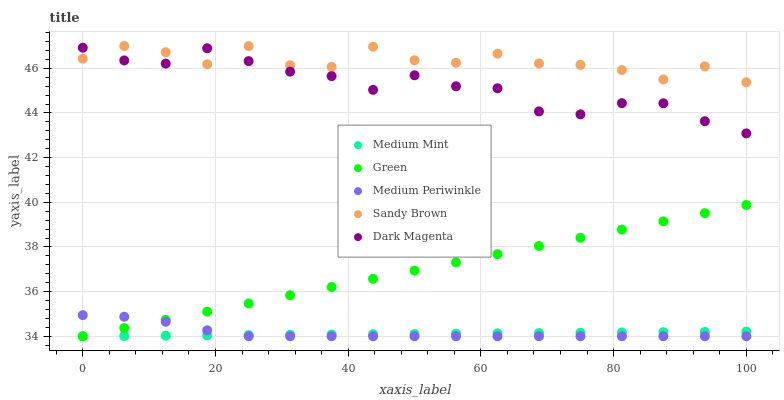Does Medium Mint have the minimum area under the curve?
Answer yes or no. Yes. Does Sandy Brown have the maximum area under the curve?
Answer yes or no. Yes. Does Medium Periwinkle have the minimum area under the curve?
Answer yes or no. No. Does Medium Periwinkle have the maximum area under the curve?
Answer yes or no. No. Is Green the smoothest?
Answer yes or no. Yes. Is Sandy Brown the roughest?
Answer yes or no. Yes. Is Medium Periwinkle the smoothest?
Answer yes or no. No. Is Medium Periwinkle the roughest?
Answer yes or no. No. Does Medium Mint have the lowest value?
Answer yes or no. Yes. Does Dark Magenta have the lowest value?
Answer yes or no. No. Does Sandy Brown have the highest value?
Answer yes or no. Yes. Does Medium Periwinkle have the highest value?
Answer yes or no. No. Is Green less than Sandy Brown?
Answer yes or no. Yes. Is Sandy Brown greater than Medium Mint?
Answer yes or no. Yes. Does Medium Periwinkle intersect Green?
Answer yes or no. Yes. Is Medium Periwinkle less than Green?
Answer yes or no. No. Is Medium Periwinkle greater than Green?
Answer yes or no. No. Does Green intersect Sandy Brown?
Answer yes or no. No. 